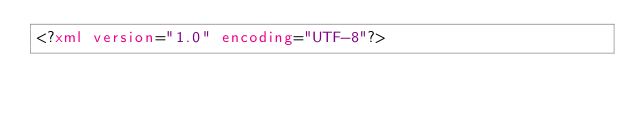<code> <loc_0><loc_0><loc_500><loc_500><_XML_><?xml version="1.0" encoding="UTF-8"?></code> 